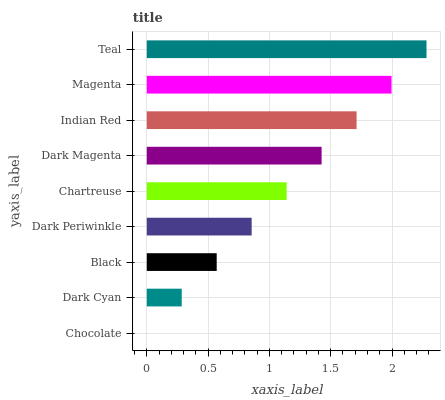Is Chocolate the minimum?
Answer yes or no. Yes. Is Teal the maximum?
Answer yes or no. Yes. Is Dark Cyan the minimum?
Answer yes or no. No. Is Dark Cyan the maximum?
Answer yes or no. No. Is Dark Cyan greater than Chocolate?
Answer yes or no. Yes. Is Chocolate less than Dark Cyan?
Answer yes or no. Yes. Is Chocolate greater than Dark Cyan?
Answer yes or no. No. Is Dark Cyan less than Chocolate?
Answer yes or no. No. Is Chartreuse the high median?
Answer yes or no. Yes. Is Chartreuse the low median?
Answer yes or no. Yes. Is Black the high median?
Answer yes or no. No. Is Indian Red the low median?
Answer yes or no. No. 